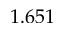<formula> <loc_0><loc_0><loc_500><loc_500>1 . 6 5 1</formula> 